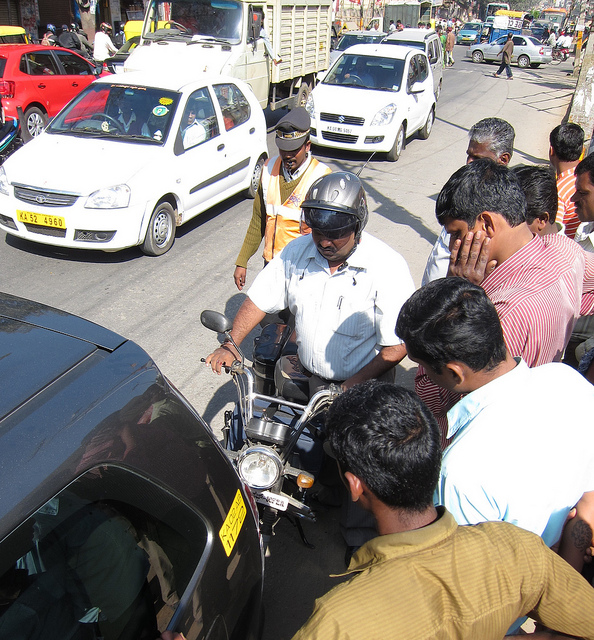Please transcribe the text information in this image. KA 52 4950 1172 1175 